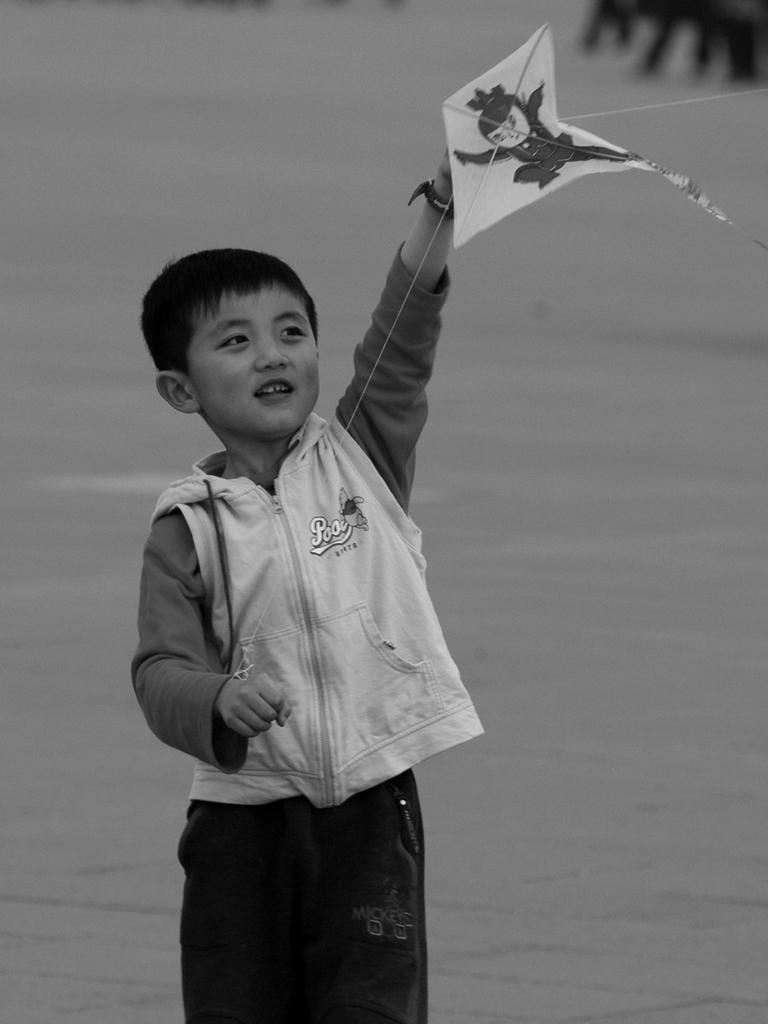Who is the main subject in the image? There is a boy in the image. Where is the boy located in relation to the image? The boy is in the foreground. What is the boy holding in the image? The boy is holding a kite. What type of minister is depicted in the image? There is no minister present in the image; it features a boy holding a kite. How many tomatoes can be seen in the image? There are no tomatoes present in the image. 